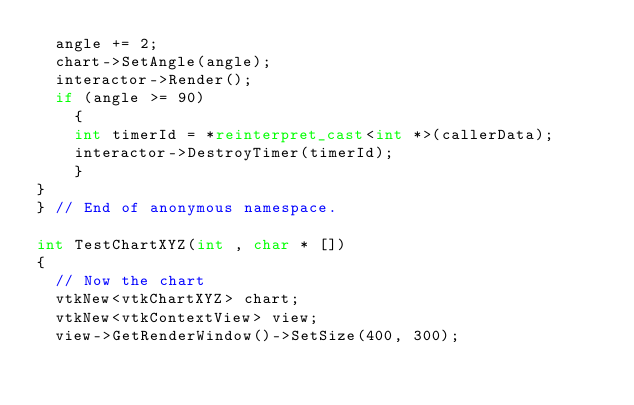Convert code to text. <code><loc_0><loc_0><loc_500><loc_500><_C++_>  angle += 2;
  chart->SetAngle(angle);
  interactor->Render();
  if (angle >= 90)
    {
    int timerId = *reinterpret_cast<int *>(callerData);
    interactor->DestroyTimer(timerId);
    }
}
} // End of anonymous namespace.

int TestChartXYZ(int , char * [])
{
  // Now the chart
  vtkNew<vtkChartXYZ> chart;
  vtkNew<vtkContextView> view;
  view->GetRenderWindow()->SetSize(400, 300);</code> 